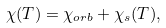<formula> <loc_0><loc_0><loc_500><loc_500>\chi ( T ) = \chi _ { o r b } + \chi _ { s } ( T ) ,</formula> 